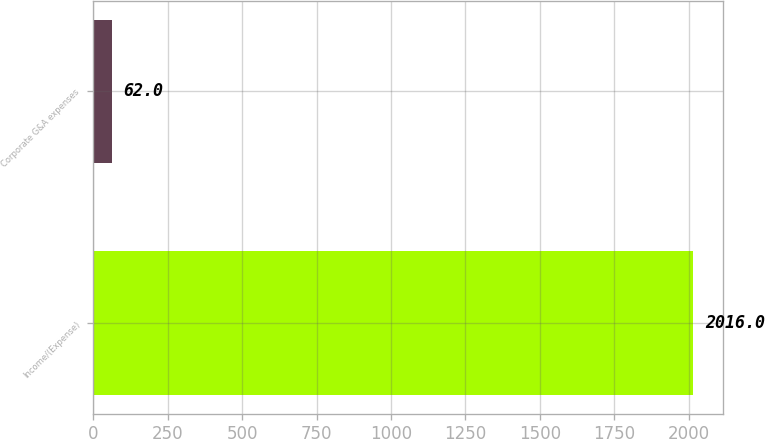Convert chart to OTSL. <chart><loc_0><loc_0><loc_500><loc_500><bar_chart><fcel>Income/(Expense)<fcel>Corporate G&A expenses<nl><fcel>2016<fcel>62<nl></chart> 